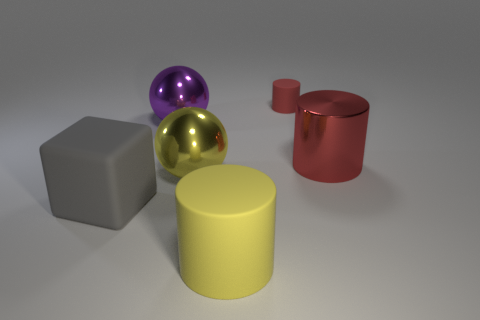Subtract all tiny cylinders. How many cylinders are left? 2 Subtract all yellow cylinders. How many cylinders are left? 2 Subtract all spheres. How many objects are left? 4 Subtract 2 cylinders. How many cylinders are left? 1 Subtract all gray balls. How many red cylinders are left? 2 Subtract all gray blocks. Subtract all big metal things. How many objects are left? 2 Add 1 gray rubber objects. How many gray rubber objects are left? 2 Add 3 large purple metal things. How many large purple metal things exist? 4 Add 1 purple objects. How many objects exist? 7 Subtract 1 purple balls. How many objects are left? 5 